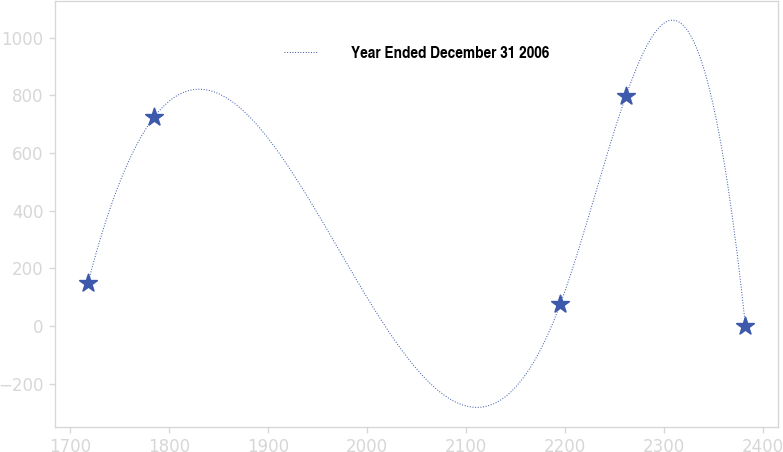Convert chart. <chart><loc_0><loc_0><loc_500><loc_500><line_chart><ecel><fcel>Year Ended December 31 2006<nl><fcel>1718.03<fcel>151.25<nl><fcel>1784.43<fcel>723.99<nl><fcel>2194.98<fcel>76.2<nl><fcel>2261.38<fcel>799.04<nl><fcel>2382.07<fcel>1.15<nl></chart> 